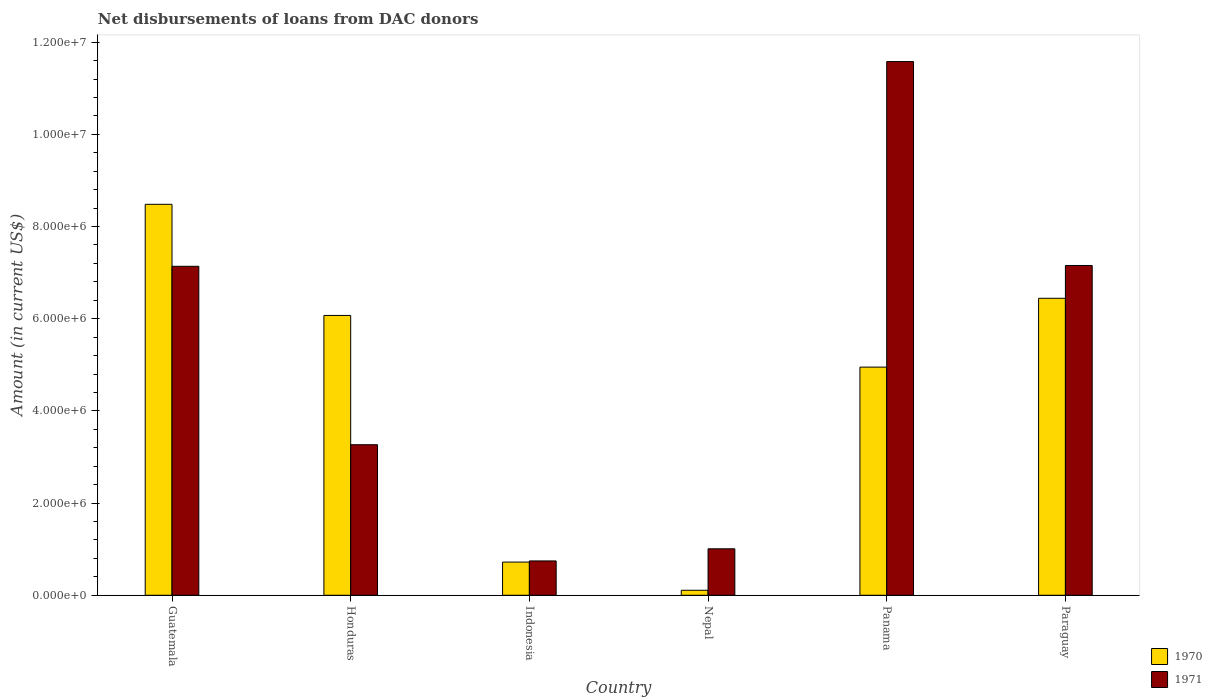How many different coloured bars are there?
Ensure brevity in your answer.  2. How many groups of bars are there?
Your answer should be very brief. 6. Are the number of bars on each tick of the X-axis equal?
Keep it short and to the point. Yes. How many bars are there on the 5th tick from the left?
Offer a very short reply. 2. What is the label of the 2nd group of bars from the left?
Keep it short and to the point. Honduras. What is the amount of loans disbursed in 1971 in Nepal?
Ensure brevity in your answer.  1.01e+06. Across all countries, what is the maximum amount of loans disbursed in 1971?
Ensure brevity in your answer.  1.16e+07. Across all countries, what is the minimum amount of loans disbursed in 1970?
Make the answer very short. 1.09e+05. In which country was the amount of loans disbursed in 1970 maximum?
Keep it short and to the point. Guatemala. In which country was the amount of loans disbursed in 1970 minimum?
Your answer should be compact. Nepal. What is the total amount of loans disbursed in 1970 in the graph?
Your response must be concise. 2.68e+07. What is the difference between the amount of loans disbursed in 1971 in Guatemala and that in Panama?
Offer a terse response. -4.44e+06. What is the difference between the amount of loans disbursed in 1970 in Guatemala and the amount of loans disbursed in 1971 in Paraguay?
Offer a very short reply. 1.33e+06. What is the average amount of loans disbursed in 1970 per country?
Provide a succinct answer. 4.46e+06. What is the difference between the amount of loans disbursed of/in 1970 and amount of loans disbursed of/in 1971 in Panama?
Provide a succinct answer. -6.63e+06. In how many countries, is the amount of loans disbursed in 1971 greater than 10000000 US$?
Your answer should be compact. 1. What is the ratio of the amount of loans disbursed in 1970 in Honduras to that in Nepal?
Provide a short and direct response. 55.7. Is the difference between the amount of loans disbursed in 1970 in Indonesia and Paraguay greater than the difference between the amount of loans disbursed in 1971 in Indonesia and Paraguay?
Your response must be concise. Yes. What is the difference between the highest and the second highest amount of loans disbursed in 1971?
Make the answer very short. 4.42e+06. What is the difference between the highest and the lowest amount of loans disbursed in 1970?
Your response must be concise. 8.37e+06. In how many countries, is the amount of loans disbursed in 1970 greater than the average amount of loans disbursed in 1970 taken over all countries?
Offer a terse response. 4. How many countries are there in the graph?
Your answer should be compact. 6. How many legend labels are there?
Offer a very short reply. 2. What is the title of the graph?
Offer a very short reply. Net disbursements of loans from DAC donors. What is the label or title of the Y-axis?
Provide a succinct answer. Amount (in current US$). What is the Amount (in current US$) of 1970 in Guatemala?
Provide a short and direct response. 8.48e+06. What is the Amount (in current US$) of 1971 in Guatemala?
Provide a succinct answer. 7.14e+06. What is the Amount (in current US$) in 1970 in Honduras?
Your response must be concise. 6.07e+06. What is the Amount (in current US$) in 1971 in Honduras?
Your answer should be compact. 3.27e+06. What is the Amount (in current US$) of 1970 in Indonesia?
Your response must be concise. 7.20e+05. What is the Amount (in current US$) of 1971 in Indonesia?
Provide a short and direct response. 7.45e+05. What is the Amount (in current US$) of 1970 in Nepal?
Ensure brevity in your answer.  1.09e+05. What is the Amount (in current US$) in 1971 in Nepal?
Provide a short and direct response. 1.01e+06. What is the Amount (in current US$) of 1970 in Panama?
Make the answer very short. 4.95e+06. What is the Amount (in current US$) in 1971 in Panama?
Offer a very short reply. 1.16e+07. What is the Amount (in current US$) of 1970 in Paraguay?
Keep it short and to the point. 6.44e+06. What is the Amount (in current US$) in 1971 in Paraguay?
Ensure brevity in your answer.  7.16e+06. Across all countries, what is the maximum Amount (in current US$) of 1970?
Your answer should be compact. 8.48e+06. Across all countries, what is the maximum Amount (in current US$) in 1971?
Provide a short and direct response. 1.16e+07. Across all countries, what is the minimum Amount (in current US$) of 1970?
Make the answer very short. 1.09e+05. Across all countries, what is the minimum Amount (in current US$) of 1971?
Make the answer very short. 7.45e+05. What is the total Amount (in current US$) in 1970 in the graph?
Your answer should be very brief. 2.68e+07. What is the total Amount (in current US$) of 1971 in the graph?
Make the answer very short. 3.09e+07. What is the difference between the Amount (in current US$) in 1970 in Guatemala and that in Honduras?
Provide a succinct answer. 2.41e+06. What is the difference between the Amount (in current US$) of 1971 in Guatemala and that in Honduras?
Your response must be concise. 3.87e+06. What is the difference between the Amount (in current US$) in 1970 in Guatemala and that in Indonesia?
Offer a terse response. 7.76e+06. What is the difference between the Amount (in current US$) in 1971 in Guatemala and that in Indonesia?
Provide a short and direct response. 6.39e+06. What is the difference between the Amount (in current US$) of 1970 in Guatemala and that in Nepal?
Provide a short and direct response. 8.37e+06. What is the difference between the Amount (in current US$) in 1971 in Guatemala and that in Nepal?
Offer a very short reply. 6.13e+06. What is the difference between the Amount (in current US$) of 1970 in Guatemala and that in Panama?
Offer a very short reply. 3.53e+06. What is the difference between the Amount (in current US$) in 1971 in Guatemala and that in Panama?
Your answer should be compact. -4.44e+06. What is the difference between the Amount (in current US$) in 1970 in Guatemala and that in Paraguay?
Provide a succinct answer. 2.04e+06. What is the difference between the Amount (in current US$) in 1971 in Guatemala and that in Paraguay?
Provide a succinct answer. -1.80e+04. What is the difference between the Amount (in current US$) in 1970 in Honduras and that in Indonesia?
Provide a short and direct response. 5.35e+06. What is the difference between the Amount (in current US$) of 1971 in Honduras and that in Indonesia?
Keep it short and to the point. 2.52e+06. What is the difference between the Amount (in current US$) in 1970 in Honduras and that in Nepal?
Your answer should be very brief. 5.96e+06. What is the difference between the Amount (in current US$) of 1971 in Honduras and that in Nepal?
Make the answer very short. 2.26e+06. What is the difference between the Amount (in current US$) of 1970 in Honduras and that in Panama?
Your answer should be compact. 1.12e+06. What is the difference between the Amount (in current US$) of 1971 in Honduras and that in Panama?
Provide a succinct answer. -8.31e+06. What is the difference between the Amount (in current US$) in 1970 in Honduras and that in Paraguay?
Provide a short and direct response. -3.72e+05. What is the difference between the Amount (in current US$) of 1971 in Honduras and that in Paraguay?
Your response must be concise. -3.89e+06. What is the difference between the Amount (in current US$) of 1970 in Indonesia and that in Nepal?
Your answer should be very brief. 6.11e+05. What is the difference between the Amount (in current US$) of 1971 in Indonesia and that in Nepal?
Provide a succinct answer. -2.63e+05. What is the difference between the Amount (in current US$) in 1970 in Indonesia and that in Panama?
Your answer should be compact. -4.23e+06. What is the difference between the Amount (in current US$) of 1971 in Indonesia and that in Panama?
Make the answer very short. -1.08e+07. What is the difference between the Amount (in current US$) in 1970 in Indonesia and that in Paraguay?
Your answer should be compact. -5.72e+06. What is the difference between the Amount (in current US$) in 1971 in Indonesia and that in Paraguay?
Ensure brevity in your answer.  -6.41e+06. What is the difference between the Amount (in current US$) of 1970 in Nepal and that in Panama?
Your answer should be compact. -4.84e+06. What is the difference between the Amount (in current US$) of 1971 in Nepal and that in Panama?
Offer a terse response. -1.06e+07. What is the difference between the Amount (in current US$) in 1970 in Nepal and that in Paraguay?
Give a very brief answer. -6.33e+06. What is the difference between the Amount (in current US$) in 1971 in Nepal and that in Paraguay?
Your response must be concise. -6.15e+06. What is the difference between the Amount (in current US$) of 1970 in Panama and that in Paraguay?
Your answer should be compact. -1.49e+06. What is the difference between the Amount (in current US$) of 1971 in Panama and that in Paraguay?
Make the answer very short. 4.42e+06. What is the difference between the Amount (in current US$) in 1970 in Guatemala and the Amount (in current US$) in 1971 in Honduras?
Provide a succinct answer. 5.22e+06. What is the difference between the Amount (in current US$) of 1970 in Guatemala and the Amount (in current US$) of 1971 in Indonesia?
Offer a terse response. 7.74e+06. What is the difference between the Amount (in current US$) of 1970 in Guatemala and the Amount (in current US$) of 1971 in Nepal?
Offer a very short reply. 7.47e+06. What is the difference between the Amount (in current US$) of 1970 in Guatemala and the Amount (in current US$) of 1971 in Panama?
Your answer should be compact. -3.10e+06. What is the difference between the Amount (in current US$) in 1970 in Guatemala and the Amount (in current US$) in 1971 in Paraguay?
Provide a short and direct response. 1.33e+06. What is the difference between the Amount (in current US$) in 1970 in Honduras and the Amount (in current US$) in 1971 in Indonesia?
Give a very brief answer. 5.33e+06. What is the difference between the Amount (in current US$) in 1970 in Honduras and the Amount (in current US$) in 1971 in Nepal?
Your response must be concise. 5.06e+06. What is the difference between the Amount (in current US$) of 1970 in Honduras and the Amount (in current US$) of 1971 in Panama?
Make the answer very short. -5.51e+06. What is the difference between the Amount (in current US$) in 1970 in Honduras and the Amount (in current US$) in 1971 in Paraguay?
Provide a short and direct response. -1.08e+06. What is the difference between the Amount (in current US$) in 1970 in Indonesia and the Amount (in current US$) in 1971 in Nepal?
Provide a succinct answer. -2.88e+05. What is the difference between the Amount (in current US$) in 1970 in Indonesia and the Amount (in current US$) in 1971 in Panama?
Your answer should be compact. -1.09e+07. What is the difference between the Amount (in current US$) in 1970 in Indonesia and the Amount (in current US$) in 1971 in Paraguay?
Your answer should be very brief. -6.44e+06. What is the difference between the Amount (in current US$) in 1970 in Nepal and the Amount (in current US$) in 1971 in Panama?
Your response must be concise. -1.15e+07. What is the difference between the Amount (in current US$) in 1970 in Nepal and the Amount (in current US$) in 1971 in Paraguay?
Make the answer very short. -7.05e+06. What is the difference between the Amount (in current US$) of 1970 in Panama and the Amount (in current US$) of 1971 in Paraguay?
Offer a terse response. -2.20e+06. What is the average Amount (in current US$) of 1970 per country?
Offer a very short reply. 4.46e+06. What is the average Amount (in current US$) in 1971 per country?
Your answer should be compact. 5.15e+06. What is the difference between the Amount (in current US$) in 1970 and Amount (in current US$) in 1971 in Guatemala?
Your answer should be very brief. 1.34e+06. What is the difference between the Amount (in current US$) in 1970 and Amount (in current US$) in 1971 in Honduras?
Provide a short and direct response. 2.80e+06. What is the difference between the Amount (in current US$) in 1970 and Amount (in current US$) in 1971 in Indonesia?
Your answer should be compact. -2.50e+04. What is the difference between the Amount (in current US$) in 1970 and Amount (in current US$) in 1971 in Nepal?
Offer a terse response. -8.99e+05. What is the difference between the Amount (in current US$) in 1970 and Amount (in current US$) in 1971 in Panama?
Ensure brevity in your answer.  -6.63e+06. What is the difference between the Amount (in current US$) in 1970 and Amount (in current US$) in 1971 in Paraguay?
Give a very brief answer. -7.12e+05. What is the ratio of the Amount (in current US$) of 1970 in Guatemala to that in Honduras?
Keep it short and to the point. 1.4. What is the ratio of the Amount (in current US$) in 1971 in Guatemala to that in Honduras?
Your answer should be very brief. 2.19. What is the ratio of the Amount (in current US$) in 1970 in Guatemala to that in Indonesia?
Provide a succinct answer. 11.78. What is the ratio of the Amount (in current US$) of 1971 in Guatemala to that in Indonesia?
Offer a very short reply. 9.58. What is the ratio of the Amount (in current US$) of 1970 in Guatemala to that in Nepal?
Give a very brief answer. 77.82. What is the ratio of the Amount (in current US$) of 1971 in Guatemala to that in Nepal?
Make the answer very short. 7.08. What is the ratio of the Amount (in current US$) of 1970 in Guatemala to that in Panama?
Give a very brief answer. 1.71. What is the ratio of the Amount (in current US$) of 1971 in Guatemala to that in Panama?
Your answer should be compact. 0.62. What is the ratio of the Amount (in current US$) of 1970 in Guatemala to that in Paraguay?
Give a very brief answer. 1.32. What is the ratio of the Amount (in current US$) in 1971 in Guatemala to that in Paraguay?
Give a very brief answer. 1. What is the ratio of the Amount (in current US$) of 1970 in Honduras to that in Indonesia?
Provide a succinct answer. 8.43. What is the ratio of the Amount (in current US$) in 1971 in Honduras to that in Indonesia?
Your answer should be compact. 4.38. What is the ratio of the Amount (in current US$) in 1970 in Honduras to that in Nepal?
Offer a very short reply. 55.7. What is the ratio of the Amount (in current US$) in 1971 in Honduras to that in Nepal?
Offer a terse response. 3.24. What is the ratio of the Amount (in current US$) in 1970 in Honduras to that in Panama?
Offer a terse response. 1.23. What is the ratio of the Amount (in current US$) of 1971 in Honduras to that in Panama?
Your answer should be compact. 0.28. What is the ratio of the Amount (in current US$) in 1970 in Honduras to that in Paraguay?
Give a very brief answer. 0.94. What is the ratio of the Amount (in current US$) of 1971 in Honduras to that in Paraguay?
Keep it short and to the point. 0.46. What is the ratio of the Amount (in current US$) of 1970 in Indonesia to that in Nepal?
Provide a succinct answer. 6.61. What is the ratio of the Amount (in current US$) of 1971 in Indonesia to that in Nepal?
Your answer should be compact. 0.74. What is the ratio of the Amount (in current US$) of 1970 in Indonesia to that in Panama?
Your answer should be very brief. 0.15. What is the ratio of the Amount (in current US$) in 1971 in Indonesia to that in Panama?
Your answer should be compact. 0.06. What is the ratio of the Amount (in current US$) of 1970 in Indonesia to that in Paraguay?
Provide a succinct answer. 0.11. What is the ratio of the Amount (in current US$) of 1971 in Indonesia to that in Paraguay?
Your answer should be compact. 0.1. What is the ratio of the Amount (in current US$) of 1970 in Nepal to that in Panama?
Your answer should be very brief. 0.02. What is the ratio of the Amount (in current US$) in 1971 in Nepal to that in Panama?
Provide a short and direct response. 0.09. What is the ratio of the Amount (in current US$) of 1970 in Nepal to that in Paraguay?
Offer a very short reply. 0.02. What is the ratio of the Amount (in current US$) of 1971 in Nepal to that in Paraguay?
Ensure brevity in your answer.  0.14. What is the ratio of the Amount (in current US$) of 1970 in Panama to that in Paraguay?
Offer a very short reply. 0.77. What is the ratio of the Amount (in current US$) in 1971 in Panama to that in Paraguay?
Make the answer very short. 1.62. What is the difference between the highest and the second highest Amount (in current US$) of 1970?
Offer a very short reply. 2.04e+06. What is the difference between the highest and the second highest Amount (in current US$) in 1971?
Your answer should be compact. 4.42e+06. What is the difference between the highest and the lowest Amount (in current US$) in 1970?
Keep it short and to the point. 8.37e+06. What is the difference between the highest and the lowest Amount (in current US$) in 1971?
Offer a very short reply. 1.08e+07. 